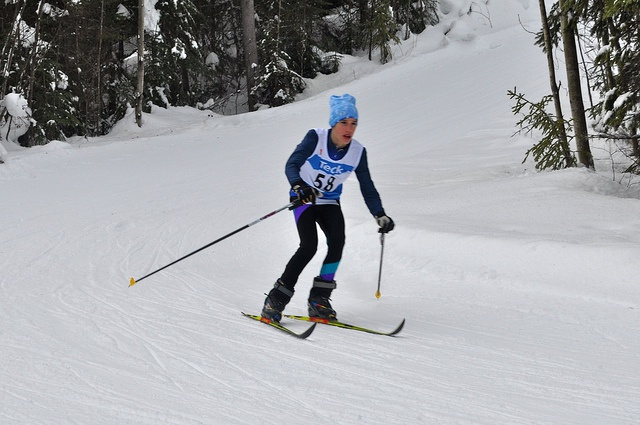Describe the objects in this image and their specific colors. I can see people in black, lightgray, darkgray, and navy tones and skis in black, gray, darkgreen, and olive tones in this image. 